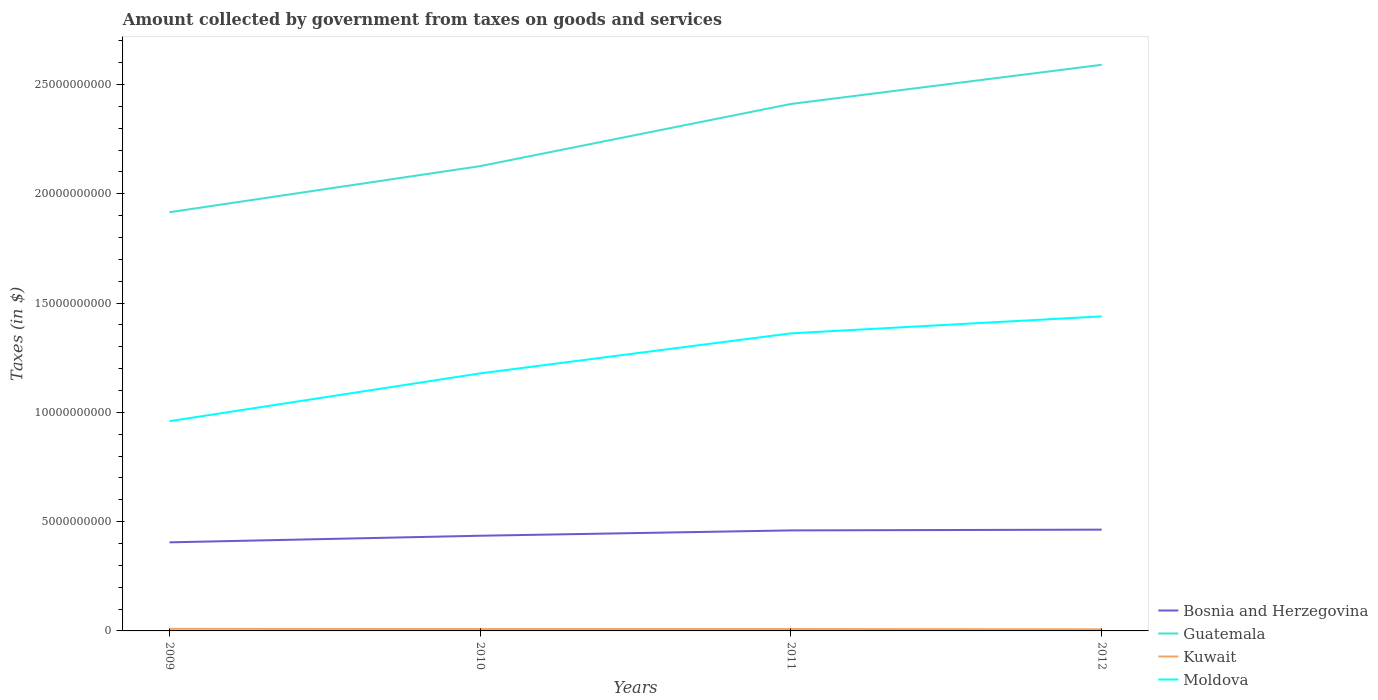How many different coloured lines are there?
Offer a very short reply. 4. Is the number of lines equal to the number of legend labels?
Ensure brevity in your answer.  Yes. Across all years, what is the maximum amount collected by government from taxes on goods and services in Kuwait?
Provide a succinct answer. 7.40e+07. In which year was the amount collected by government from taxes on goods and services in Bosnia and Herzegovina maximum?
Make the answer very short. 2009. What is the total amount collected by government from taxes on goods and services in Bosnia and Herzegovina in the graph?
Offer a terse response. -5.46e+08. What is the difference between the highest and the second highest amount collected by government from taxes on goods and services in Guatemala?
Ensure brevity in your answer.  6.75e+09. Is the amount collected by government from taxes on goods and services in Guatemala strictly greater than the amount collected by government from taxes on goods and services in Kuwait over the years?
Your response must be concise. No. How many lines are there?
Offer a terse response. 4. Where does the legend appear in the graph?
Keep it short and to the point. Bottom right. How are the legend labels stacked?
Provide a short and direct response. Vertical. What is the title of the graph?
Your response must be concise. Amount collected by government from taxes on goods and services. Does "Italy" appear as one of the legend labels in the graph?
Give a very brief answer. No. What is the label or title of the X-axis?
Ensure brevity in your answer.  Years. What is the label or title of the Y-axis?
Your answer should be compact. Taxes (in $). What is the Taxes (in $) of Bosnia and Herzegovina in 2009?
Offer a very short reply. 4.05e+09. What is the Taxes (in $) in Guatemala in 2009?
Keep it short and to the point. 1.92e+1. What is the Taxes (in $) in Kuwait in 2009?
Your answer should be very brief. 9.40e+07. What is the Taxes (in $) of Moldova in 2009?
Ensure brevity in your answer.  9.60e+09. What is the Taxes (in $) of Bosnia and Herzegovina in 2010?
Offer a very short reply. 4.35e+09. What is the Taxes (in $) of Guatemala in 2010?
Your response must be concise. 2.13e+1. What is the Taxes (in $) of Kuwait in 2010?
Ensure brevity in your answer.  8.80e+07. What is the Taxes (in $) in Moldova in 2010?
Give a very brief answer. 1.18e+1. What is the Taxes (in $) of Bosnia and Herzegovina in 2011?
Make the answer very short. 4.60e+09. What is the Taxes (in $) in Guatemala in 2011?
Make the answer very short. 2.41e+1. What is the Taxes (in $) in Kuwait in 2011?
Give a very brief answer. 8.60e+07. What is the Taxes (in $) in Moldova in 2011?
Your response must be concise. 1.36e+1. What is the Taxes (in $) in Bosnia and Herzegovina in 2012?
Offer a very short reply. 4.63e+09. What is the Taxes (in $) of Guatemala in 2012?
Provide a short and direct response. 2.59e+1. What is the Taxes (in $) of Kuwait in 2012?
Your answer should be compact. 7.40e+07. What is the Taxes (in $) in Moldova in 2012?
Give a very brief answer. 1.44e+1. Across all years, what is the maximum Taxes (in $) of Bosnia and Herzegovina?
Your answer should be very brief. 4.63e+09. Across all years, what is the maximum Taxes (in $) in Guatemala?
Provide a short and direct response. 2.59e+1. Across all years, what is the maximum Taxes (in $) of Kuwait?
Provide a short and direct response. 9.40e+07. Across all years, what is the maximum Taxes (in $) in Moldova?
Make the answer very short. 1.44e+1. Across all years, what is the minimum Taxes (in $) in Bosnia and Herzegovina?
Keep it short and to the point. 4.05e+09. Across all years, what is the minimum Taxes (in $) in Guatemala?
Keep it short and to the point. 1.92e+1. Across all years, what is the minimum Taxes (in $) of Kuwait?
Provide a succinct answer. 7.40e+07. Across all years, what is the minimum Taxes (in $) of Moldova?
Make the answer very short. 9.60e+09. What is the total Taxes (in $) in Bosnia and Herzegovina in the graph?
Ensure brevity in your answer.  1.76e+1. What is the total Taxes (in $) of Guatemala in the graph?
Your response must be concise. 9.04e+1. What is the total Taxes (in $) in Kuwait in the graph?
Keep it short and to the point. 3.42e+08. What is the total Taxes (in $) in Moldova in the graph?
Your answer should be compact. 4.94e+1. What is the difference between the Taxes (in $) in Bosnia and Herzegovina in 2009 and that in 2010?
Offer a very short reply. -3.02e+08. What is the difference between the Taxes (in $) of Guatemala in 2009 and that in 2010?
Offer a very short reply. -2.11e+09. What is the difference between the Taxes (in $) in Moldova in 2009 and that in 2010?
Offer a very short reply. -2.19e+09. What is the difference between the Taxes (in $) in Bosnia and Herzegovina in 2009 and that in 2011?
Ensure brevity in your answer.  -5.46e+08. What is the difference between the Taxes (in $) of Guatemala in 2009 and that in 2011?
Your response must be concise. -4.95e+09. What is the difference between the Taxes (in $) in Moldova in 2009 and that in 2011?
Make the answer very short. -4.02e+09. What is the difference between the Taxes (in $) in Bosnia and Herzegovina in 2009 and that in 2012?
Your answer should be compact. -5.81e+08. What is the difference between the Taxes (in $) in Guatemala in 2009 and that in 2012?
Provide a short and direct response. -6.75e+09. What is the difference between the Taxes (in $) in Moldova in 2009 and that in 2012?
Make the answer very short. -4.80e+09. What is the difference between the Taxes (in $) in Bosnia and Herzegovina in 2010 and that in 2011?
Provide a succinct answer. -2.44e+08. What is the difference between the Taxes (in $) in Guatemala in 2010 and that in 2011?
Keep it short and to the point. -2.84e+09. What is the difference between the Taxes (in $) in Kuwait in 2010 and that in 2011?
Make the answer very short. 2.00e+06. What is the difference between the Taxes (in $) of Moldova in 2010 and that in 2011?
Your response must be concise. -1.83e+09. What is the difference between the Taxes (in $) in Bosnia and Herzegovina in 2010 and that in 2012?
Your answer should be very brief. -2.79e+08. What is the difference between the Taxes (in $) in Guatemala in 2010 and that in 2012?
Make the answer very short. -4.64e+09. What is the difference between the Taxes (in $) in Kuwait in 2010 and that in 2012?
Your response must be concise. 1.40e+07. What is the difference between the Taxes (in $) in Moldova in 2010 and that in 2012?
Offer a very short reply. -2.61e+09. What is the difference between the Taxes (in $) of Bosnia and Herzegovina in 2011 and that in 2012?
Provide a short and direct response. -3.47e+07. What is the difference between the Taxes (in $) of Guatemala in 2011 and that in 2012?
Ensure brevity in your answer.  -1.79e+09. What is the difference between the Taxes (in $) of Kuwait in 2011 and that in 2012?
Your response must be concise. 1.20e+07. What is the difference between the Taxes (in $) of Moldova in 2011 and that in 2012?
Provide a short and direct response. -7.78e+08. What is the difference between the Taxes (in $) in Bosnia and Herzegovina in 2009 and the Taxes (in $) in Guatemala in 2010?
Make the answer very short. -1.72e+1. What is the difference between the Taxes (in $) of Bosnia and Herzegovina in 2009 and the Taxes (in $) of Kuwait in 2010?
Provide a succinct answer. 3.96e+09. What is the difference between the Taxes (in $) in Bosnia and Herzegovina in 2009 and the Taxes (in $) in Moldova in 2010?
Make the answer very short. -7.73e+09. What is the difference between the Taxes (in $) of Guatemala in 2009 and the Taxes (in $) of Kuwait in 2010?
Make the answer very short. 1.91e+1. What is the difference between the Taxes (in $) of Guatemala in 2009 and the Taxes (in $) of Moldova in 2010?
Ensure brevity in your answer.  7.37e+09. What is the difference between the Taxes (in $) in Kuwait in 2009 and the Taxes (in $) in Moldova in 2010?
Your answer should be very brief. -1.17e+1. What is the difference between the Taxes (in $) in Bosnia and Herzegovina in 2009 and the Taxes (in $) in Guatemala in 2011?
Offer a terse response. -2.01e+1. What is the difference between the Taxes (in $) of Bosnia and Herzegovina in 2009 and the Taxes (in $) of Kuwait in 2011?
Your answer should be very brief. 3.97e+09. What is the difference between the Taxes (in $) in Bosnia and Herzegovina in 2009 and the Taxes (in $) in Moldova in 2011?
Your answer should be compact. -9.56e+09. What is the difference between the Taxes (in $) of Guatemala in 2009 and the Taxes (in $) of Kuwait in 2011?
Ensure brevity in your answer.  1.91e+1. What is the difference between the Taxes (in $) in Guatemala in 2009 and the Taxes (in $) in Moldova in 2011?
Keep it short and to the point. 5.54e+09. What is the difference between the Taxes (in $) in Kuwait in 2009 and the Taxes (in $) in Moldova in 2011?
Your answer should be very brief. -1.35e+1. What is the difference between the Taxes (in $) of Bosnia and Herzegovina in 2009 and the Taxes (in $) of Guatemala in 2012?
Keep it short and to the point. -2.18e+1. What is the difference between the Taxes (in $) of Bosnia and Herzegovina in 2009 and the Taxes (in $) of Kuwait in 2012?
Ensure brevity in your answer.  3.98e+09. What is the difference between the Taxes (in $) of Bosnia and Herzegovina in 2009 and the Taxes (in $) of Moldova in 2012?
Your response must be concise. -1.03e+1. What is the difference between the Taxes (in $) of Guatemala in 2009 and the Taxes (in $) of Kuwait in 2012?
Keep it short and to the point. 1.91e+1. What is the difference between the Taxes (in $) in Guatemala in 2009 and the Taxes (in $) in Moldova in 2012?
Your response must be concise. 4.76e+09. What is the difference between the Taxes (in $) of Kuwait in 2009 and the Taxes (in $) of Moldova in 2012?
Offer a terse response. -1.43e+1. What is the difference between the Taxes (in $) of Bosnia and Herzegovina in 2010 and the Taxes (in $) of Guatemala in 2011?
Offer a terse response. -1.98e+1. What is the difference between the Taxes (in $) of Bosnia and Herzegovina in 2010 and the Taxes (in $) of Kuwait in 2011?
Your answer should be compact. 4.27e+09. What is the difference between the Taxes (in $) of Bosnia and Herzegovina in 2010 and the Taxes (in $) of Moldova in 2011?
Make the answer very short. -9.26e+09. What is the difference between the Taxes (in $) of Guatemala in 2010 and the Taxes (in $) of Kuwait in 2011?
Ensure brevity in your answer.  2.12e+1. What is the difference between the Taxes (in $) in Guatemala in 2010 and the Taxes (in $) in Moldova in 2011?
Make the answer very short. 7.65e+09. What is the difference between the Taxes (in $) in Kuwait in 2010 and the Taxes (in $) in Moldova in 2011?
Your answer should be compact. -1.35e+1. What is the difference between the Taxes (in $) of Bosnia and Herzegovina in 2010 and the Taxes (in $) of Guatemala in 2012?
Give a very brief answer. -2.15e+1. What is the difference between the Taxes (in $) in Bosnia and Herzegovina in 2010 and the Taxes (in $) in Kuwait in 2012?
Your response must be concise. 4.28e+09. What is the difference between the Taxes (in $) of Bosnia and Herzegovina in 2010 and the Taxes (in $) of Moldova in 2012?
Your response must be concise. -1.00e+1. What is the difference between the Taxes (in $) in Guatemala in 2010 and the Taxes (in $) in Kuwait in 2012?
Provide a succinct answer. 2.12e+1. What is the difference between the Taxes (in $) in Guatemala in 2010 and the Taxes (in $) in Moldova in 2012?
Provide a short and direct response. 6.87e+09. What is the difference between the Taxes (in $) in Kuwait in 2010 and the Taxes (in $) in Moldova in 2012?
Give a very brief answer. -1.43e+1. What is the difference between the Taxes (in $) in Bosnia and Herzegovina in 2011 and the Taxes (in $) in Guatemala in 2012?
Offer a very short reply. -2.13e+1. What is the difference between the Taxes (in $) in Bosnia and Herzegovina in 2011 and the Taxes (in $) in Kuwait in 2012?
Your answer should be compact. 4.53e+09. What is the difference between the Taxes (in $) in Bosnia and Herzegovina in 2011 and the Taxes (in $) in Moldova in 2012?
Ensure brevity in your answer.  -9.79e+09. What is the difference between the Taxes (in $) of Guatemala in 2011 and the Taxes (in $) of Kuwait in 2012?
Offer a very short reply. 2.40e+1. What is the difference between the Taxes (in $) in Guatemala in 2011 and the Taxes (in $) in Moldova in 2012?
Your answer should be very brief. 9.72e+09. What is the difference between the Taxes (in $) in Kuwait in 2011 and the Taxes (in $) in Moldova in 2012?
Provide a succinct answer. -1.43e+1. What is the average Taxes (in $) in Bosnia and Herzegovina per year?
Give a very brief answer. 4.41e+09. What is the average Taxes (in $) of Guatemala per year?
Your answer should be compact. 2.26e+1. What is the average Taxes (in $) in Kuwait per year?
Make the answer very short. 8.55e+07. What is the average Taxes (in $) in Moldova per year?
Provide a succinct answer. 1.23e+1. In the year 2009, what is the difference between the Taxes (in $) in Bosnia and Herzegovina and Taxes (in $) in Guatemala?
Offer a very short reply. -1.51e+1. In the year 2009, what is the difference between the Taxes (in $) in Bosnia and Herzegovina and Taxes (in $) in Kuwait?
Make the answer very short. 3.96e+09. In the year 2009, what is the difference between the Taxes (in $) of Bosnia and Herzegovina and Taxes (in $) of Moldova?
Provide a short and direct response. -5.54e+09. In the year 2009, what is the difference between the Taxes (in $) of Guatemala and Taxes (in $) of Kuwait?
Your response must be concise. 1.91e+1. In the year 2009, what is the difference between the Taxes (in $) of Guatemala and Taxes (in $) of Moldova?
Your answer should be compact. 9.56e+09. In the year 2009, what is the difference between the Taxes (in $) of Kuwait and Taxes (in $) of Moldova?
Your answer should be compact. -9.50e+09. In the year 2010, what is the difference between the Taxes (in $) of Bosnia and Herzegovina and Taxes (in $) of Guatemala?
Offer a terse response. -1.69e+1. In the year 2010, what is the difference between the Taxes (in $) of Bosnia and Herzegovina and Taxes (in $) of Kuwait?
Your answer should be compact. 4.27e+09. In the year 2010, what is the difference between the Taxes (in $) in Bosnia and Herzegovina and Taxes (in $) in Moldova?
Provide a succinct answer. -7.43e+09. In the year 2010, what is the difference between the Taxes (in $) of Guatemala and Taxes (in $) of Kuwait?
Your answer should be very brief. 2.12e+1. In the year 2010, what is the difference between the Taxes (in $) of Guatemala and Taxes (in $) of Moldova?
Offer a very short reply. 9.48e+09. In the year 2010, what is the difference between the Taxes (in $) of Kuwait and Taxes (in $) of Moldova?
Give a very brief answer. -1.17e+1. In the year 2011, what is the difference between the Taxes (in $) in Bosnia and Herzegovina and Taxes (in $) in Guatemala?
Offer a very short reply. -1.95e+1. In the year 2011, what is the difference between the Taxes (in $) in Bosnia and Herzegovina and Taxes (in $) in Kuwait?
Give a very brief answer. 4.51e+09. In the year 2011, what is the difference between the Taxes (in $) in Bosnia and Herzegovina and Taxes (in $) in Moldova?
Offer a very short reply. -9.02e+09. In the year 2011, what is the difference between the Taxes (in $) of Guatemala and Taxes (in $) of Kuwait?
Your answer should be very brief. 2.40e+1. In the year 2011, what is the difference between the Taxes (in $) in Guatemala and Taxes (in $) in Moldova?
Keep it short and to the point. 1.05e+1. In the year 2011, what is the difference between the Taxes (in $) of Kuwait and Taxes (in $) of Moldova?
Provide a succinct answer. -1.35e+1. In the year 2012, what is the difference between the Taxes (in $) of Bosnia and Herzegovina and Taxes (in $) of Guatemala?
Your answer should be compact. -2.13e+1. In the year 2012, what is the difference between the Taxes (in $) of Bosnia and Herzegovina and Taxes (in $) of Kuwait?
Make the answer very short. 4.56e+09. In the year 2012, what is the difference between the Taxes (in $) in Bosnia and Herzegovina and Taxes (in $) in Moldova?
Your response must be concise. -9.76e+09. In the year 2012, what is the difference between the Taxes (in $) of Guatemala and Taxes (in $) of Kuwait?
Your response must be concise. 2.58e+1. In the year 2012, what is the difference between the Taxes (in $) in Guatemala and Taxes (in $) in Moldova?
Give a very brief answer. 1.15e+1. In the year 2012, what is the difference between the Taxes (in $) of Kuwait and Taxes (in $) of Moldova?
Your answer should be very brief. -1.43e+1. What is the ratio of the Taxes (in $) of Bosnia and Herzegovina in 2009 to that in 2010?
Your response must be concise. 0.93. What is the ratio of the Taxes (in $) of Guatemala in 2009 to that in 2010?
Offer a very short reply. 0.9. What is the ratio of the Taxes (in $) of Kuwait in 2009 to that in 2010?
Offer a terse response. 1.07. What is the ratio of the Taxes (in $) of Moldova in 2009 to that in 2010?
Ensure brevity in your answer.  0.81. What is the ratio of the Taxes (in $) in Bosnia and Herzegovina in 2009 to that in 2011?
Your answer should be compact. 0.88. What is the ratio of the Taxes (in $) in Guatemala in 2009 to that in 2011?
Offer a very short reply. 0.79. What is the ratio of the Taxes (in $) in Kuwait in 2009 to that in 2011?
Your answer should be very brief. 1.09. What is the ratio of the Taxes (in $) of Moldova in 2009 to that in 2011?
Offer a very short reply. 0.7. What is the ratio of the Taxes (in $) in Bosnia and Herzegovina in 2009 to that in 2012?
Give a very brief answer. 0.87. What is the ratio of the Taxes (in $) of Guatemala in 2009 to that in 2012?
Your answer should be compact. 0.74. What is the ratio of the Taxes (in $) in Kuwait in 2009 to that in 2012?
Keep it short and to the point. 1.27. What is the ratio of the Taxes (in $) of Moldova in 2009 to that in 2012?
Your answer should be very brief. 0.67. What is the ratio of the Taxes (in $) in Bosnia and Herzegovina in 2010 to that in 2011?
Offer a very short reply. 0.95. What is the ratio of the Taxes (in $) in Guatemala in 2010 to that in 2011?
Provide a short and direct response. 0.88. What is the ratio of the Taxes (in $) of Kuwait in 2010 to that in 2011?
Make the answer very short. 1.02. What is the ratio of the Taxes (in $) in Moldova in 2010 to that in 2011?
Keep it short and to the point. 0.87. What is the ratio of the Taxes (in $) in Bosnia and Herzegovina in 2010 to that in 2012?
Offer a very short reply. 0.94. What is the ratio of the Taxes (in $) in Guatemala in 2010 to that in 2012?
Provide a succinct answer. 0.82. What is the ratio of the Taxes (in $) of Kuwait in 2010 to that in 2012?
Make the answer very short. 1.19. What is the ratio of the Taxes (in $) in Moldova in 2010 to that in 2012?
Your answer should be compact. 0.82. What is the ratio of the Taxes (in $) of Bosnia and Herzegovina in 2011 to that in 2012?
Your response must be concise. 0.99. What is the ratio of the Taxes (in $) in Guatemala in 2011 to that in 2012?
Provide a succinct answer. 0.93. What is the ratio of the Taxes (in $) in Kuwait in 2011 to that in 2012?
Give a very brief answer. 1.16. What is the ratio of the Taxes (in $) of Moldova in 2011 to that in 2012?
Make the answer very short. 0.95. What is the difference between the highest and the second highest Taxes (in $) in Bosnia and Herzegovina?
Offer a very short reply. 3.47e+07. What is the difference between the highest and the second highest Taxes (in $) in Guatemala?
Offer a very short reply. 1.79e+09. What is the difference between the highest and the second highest Taxes (in $) of Kuwait?
Your answer should be very brief. 6.00e+06. What is the difference between the highest and the second highest Taxes (in $) in Moldova?
Make the answer very short. 7.78e+08. What is the difference between the highest and the lowest Taxes (in $) in Bosnia and Herzegovina?
Make the answer very short. 5.81e+08. What is the difference between the highest and the lowest Taxes (in $) in Guatemala?
Your answer should be compact. 6.75e+09. What is the difference between the highest and the lowest Taxes (in $) in Moldova?
Ensure brevity in your answer.  4.80e+09. 